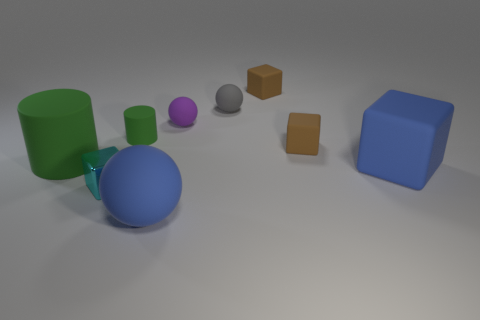How many yellow objects are either tiny cubes or small things?
Offer a terse response. 0. There is a blue thing right of the large blue matte ball; is its size the same as the blue rubber object that is in front of the large blue cube?
Offer a terse response. Yes. How many objects are either large matte spheres or green cylinders?
Give a very brief answer. 3. Are there any brown things that have the same shape as the small purple object?
Offer a very short reply. No. Is the number of yellow blocks less than the number of blue matte things?
Provide a short and direct response. Yes. Is the shape of the gray rubber object the same as the small cyan thing?
Provide a succinct answer. No. How many objects are tiny gray objects or large things that are left of the big blue matte sphere?
Your answer should be compact. 2. What number of tiny rubber things are there?
Your answer should be very brief. 5. Is there a brown rubber block of the same size as the cyan shiny thing?
Provide a short and direct response. Yes. Are there fewer small cyan shiny things that are in front of the small cyan object than small brown matte balls?
Your response must be concise. No. 